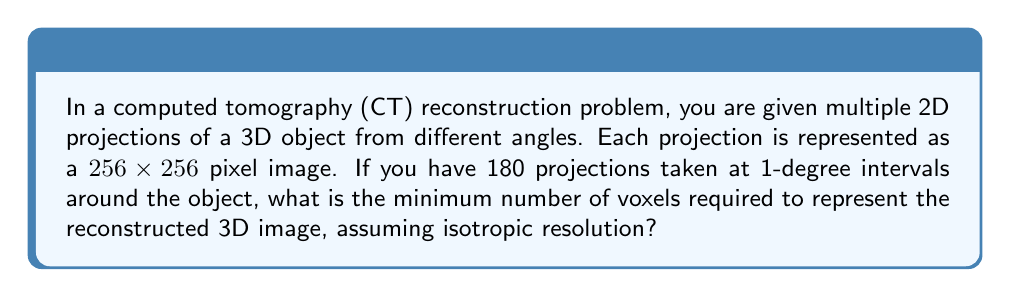Provide a solution to this math problem. To solve this problem, we need to follow these steps:

1. Understand the given information:
   - We have 2D projections of size 256x256 pixels
   - There are 180 projections taken at 1-degree intervals

2. Determine the dimensions of the 3D reconstruction:
   - The width and height of the reconstructed volume will be 256 voxels each, matching the projection dimensions
   - The depth of the volume needs to be calculated

3. Calculate the depth of the reconstructed volume:
   - In CT reconstruction, the depth is typically equal to the width of the projections
   - Therefore, the depth will also be 256 voxels

4. Calculate the total number of voxels:
   - The 3D volume dimensions are 256 x 256 x 256
   - Total number of voxels = $256 \times 256 \times 256$
   - $256^3 = 16,777,216$ voxels

Thus, the minimum number of voxels required to represent the reconstructed 3D image with isotropic resolution is 16,777,216.

Note: In practice, reconstruction algorithms like filtered back-projection or iterative reconstruction methods would be used to compute the actual voxel values from the projection data. The number calculated here represents the size of the 3D array needed to store the reconstructed image.
Answer: 16,777,216 voxels 